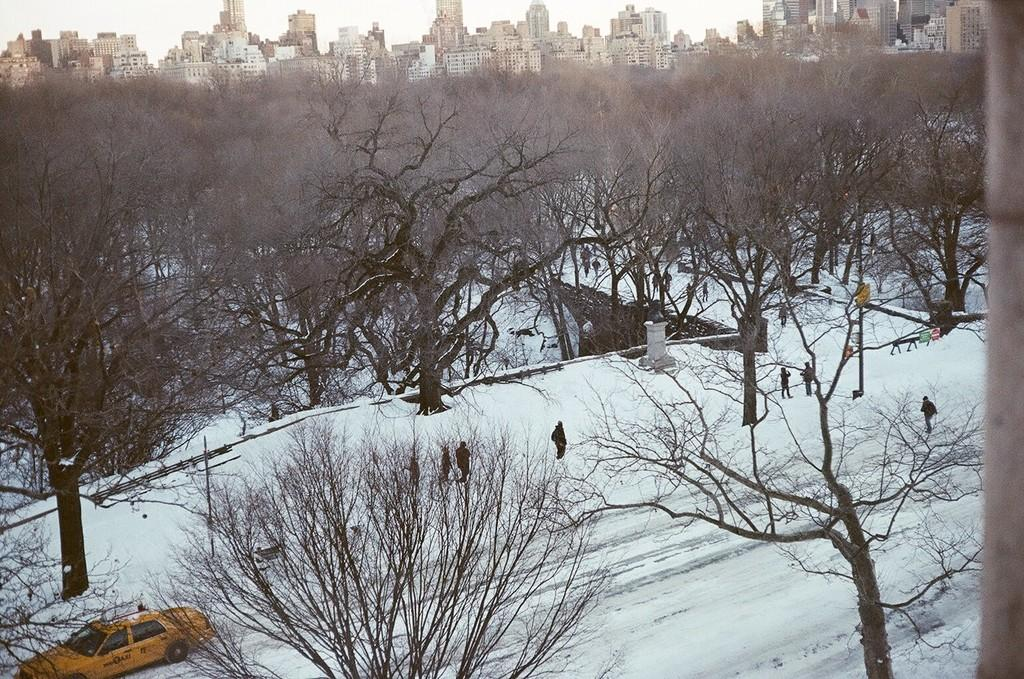What is the setting of the image? The people are in the snow, indicating a cold or winter environment. What can be seen beside the people? There are trees beside the people. Are there any signs or notices in the image? Yes, sign boards are present. What else can be seen in the image? A car is visible, and there are buildings in the background. How many mice are running on the car in the image? There are no mice present in the image; it features people in the snow, trees, sign boards, a car, and buildings in the background. 